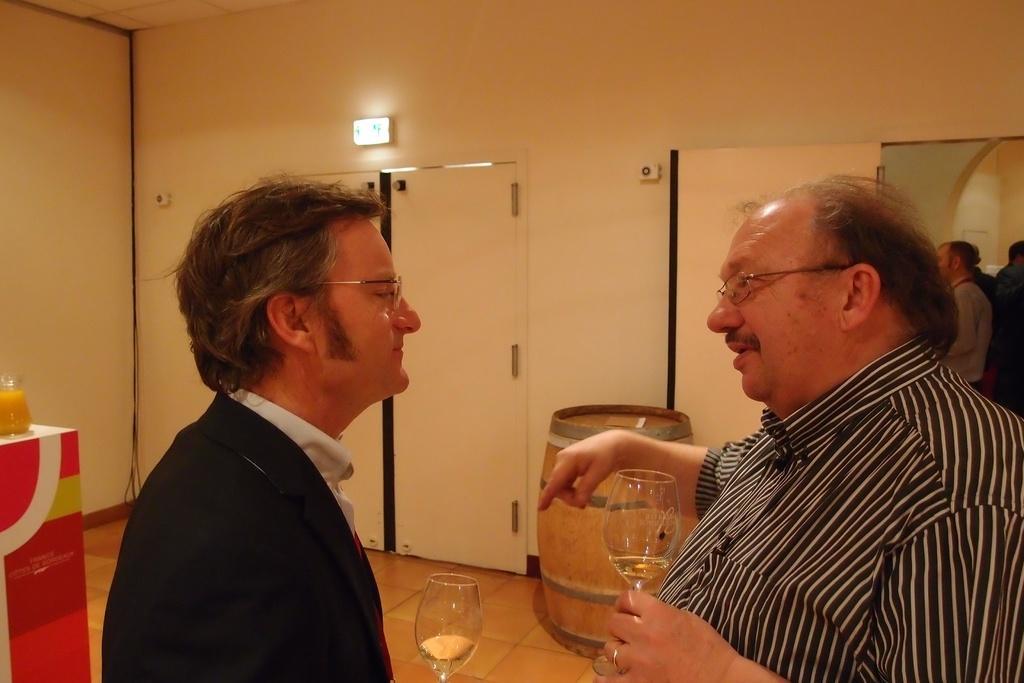Could you give a brief overview of what you see in this image? In this image, Group of people are standing, few are holding a wine glass. At the back side, we can see white color doors and wall and exit board here. On left side, there is a juice in a jar that is placed on the table. At the center of the image, there is a wooden barrel. 